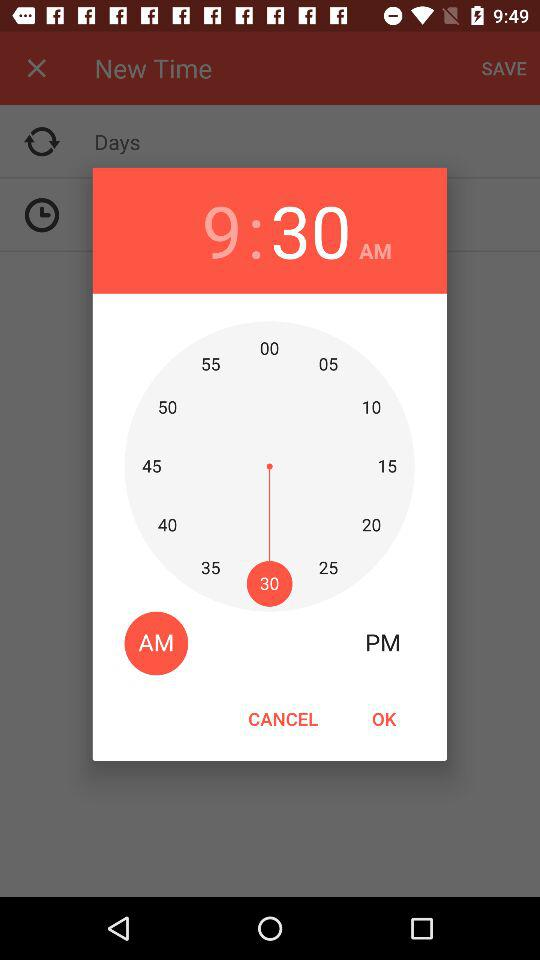What is the selected time? The selected time is 9:30 AM. 